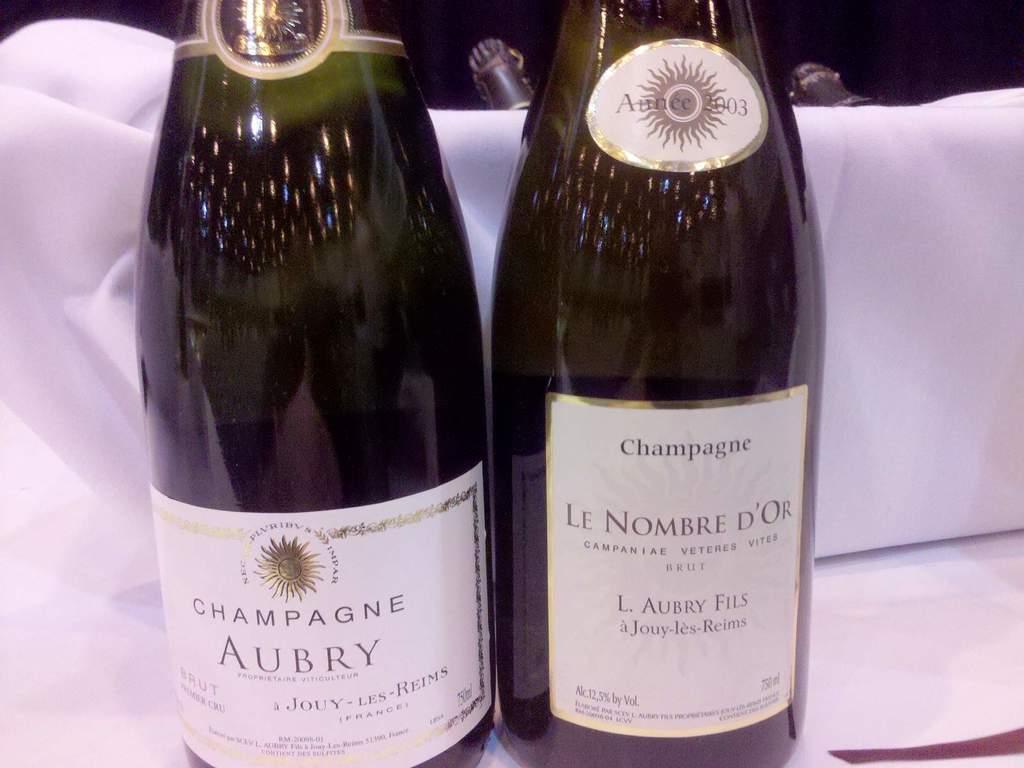What type of drink is this?
Make the answer very short. Champagne. 